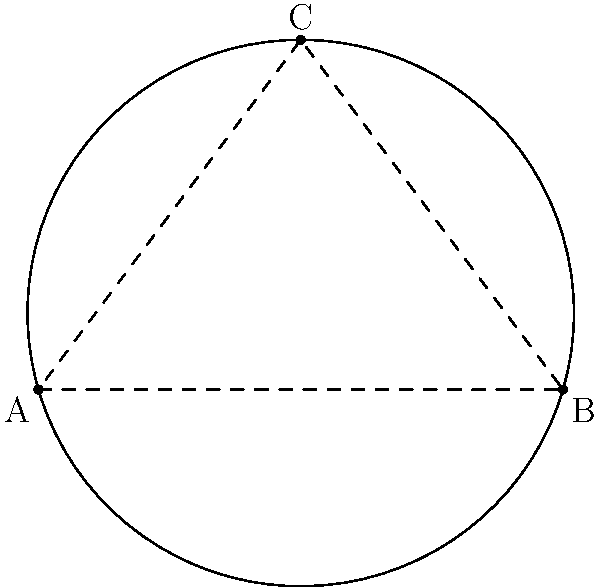As a travel agent planning a themed pool party, you're designing a circular swimming pool for a resort. Three points on the edge of the pool are given: A(0,0), B(6,0), and C(3,4). Find the center and radius of the pool to ensure proper placement of decorations and activities. To find the center and radius of the circular pool, we'll follow these steps:

1) The center of the circle is the intersection of the perpendicular bisectors of any two chords.

2) Let's choose AB and BC as our chords.

3) Midpoint of AB: $(\frac{0+6}{2}, \frac{0+0}{2}) = (3,0)$
   Midpoint of BC: $(\frac{6+3}{2}, \frac{0+4}{2}) = (4.5,2)$

4) Slope of AB: $m_{AB} = \frac{0-0}{6-0} = 0$
   Perpendicular slope: $m_{\perp AB} = -\frac{1}{0} = undefined$ (vertical line)

5) Slope of BC: $m_{BC} = \frac{4-0}{3-6} = -\frac{4}{3}$
   Perpendicular slope: $m_{\perp BC} = \frac{3}{4}$

6) Equation of perpendicular bisector of AB: $x = 3$

7) Equation of perpendicular bisector of BC: 
   $y - 2 = \frac{3}{4}(x - 4.5)$

8) Solve these equations simultaneously to find the center:
   $x = 3$
   $y - 2 = \frac{3}{4}(3 - 4.5) = -\frac{9}{8}$
   $y = 2 - \frac{9}{8} = \frac{7}{8}$

   So, the center is $(3, \frac{7}{8})$

9) To find the radius, calculate the distance from the center to any of the given points:

   $r = \sqrt{(3-0)^2 + (\frac{7}{8}-0)^2} = \sqrt{9 + \frac{49}{64}} = \sqrt{\frac{625}{64}} = \frac{25}{8} = 3.125$

Therefore, the center of the pool is at (3, 0.875) and its radius is 3.125 units.
Answer: Center: (3, 0.875), Radius: 3.125 